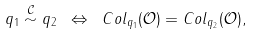<formula> <loc_0><loc_0><loc_500><loc_500>q _ { 1 } \overset { \mathcal { C } } { \sim } q _ { 2 } \ \Leftrightarrow \ C o l _ { q _ { 1 } } ( \mathcal { O } ) = C o l _ { q _ { 2 } } ( \mathcal { O } ) ,</formula> 